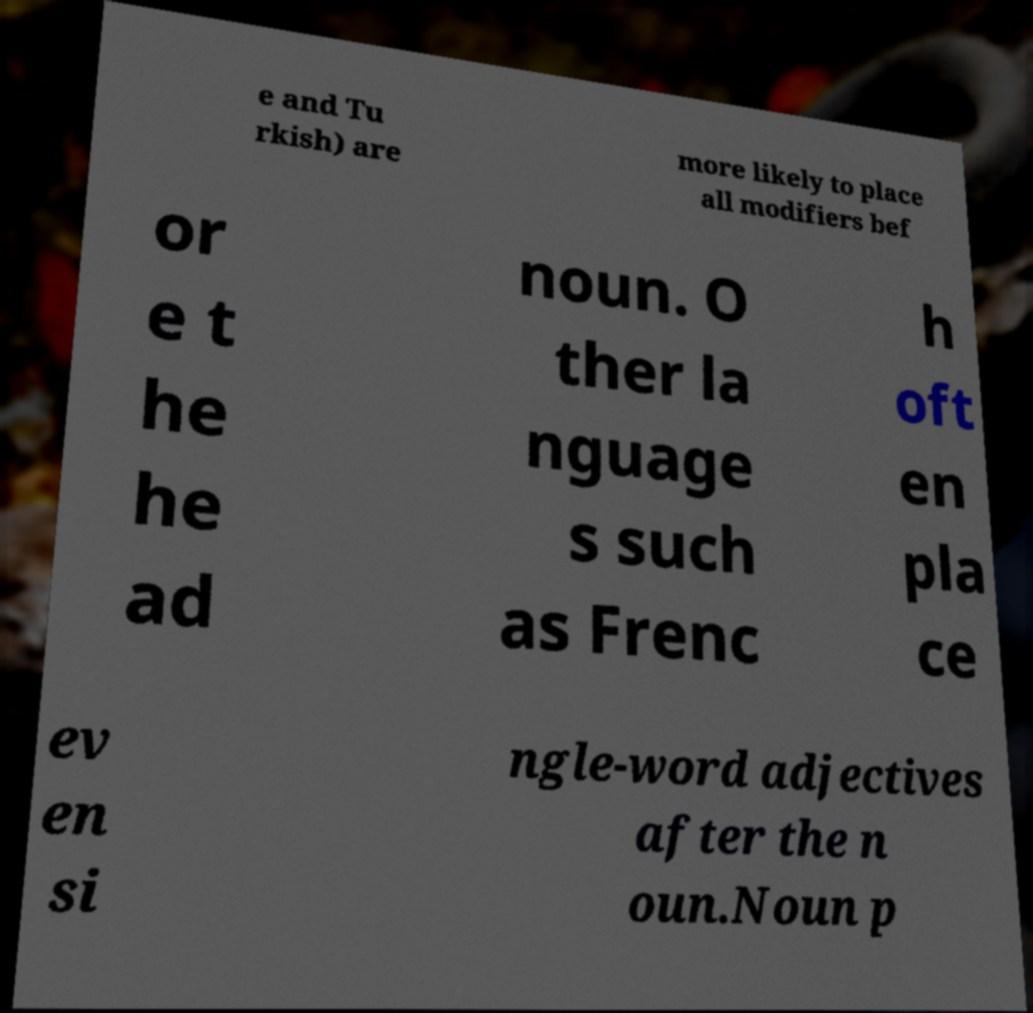Please read and relay the text visible in this image. What does it say? e and Tu rkish) are more likely to place all modifiers bef or e t he he ad noun. O ther la nguage s such as Frenc h oft en pla ce ev en si ngle-word adjectives after the n oun.Noun p 